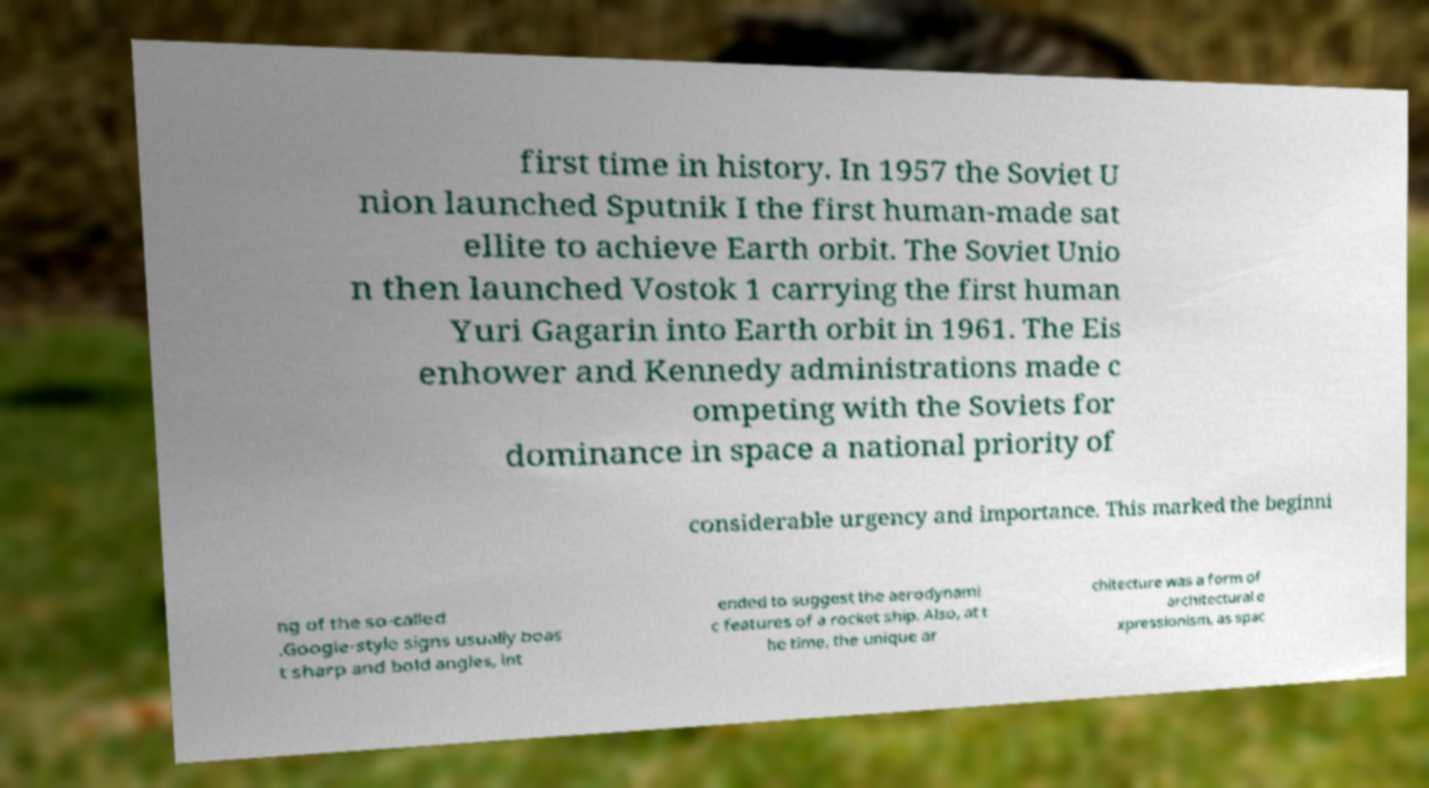Could you extract and type out the text from this image? first time in history. In 1957 the Soviet U nion launched Sputnik I the first human-made sat ellite to achieve Earth orbit. The Soviet Unio n then launched Vostok 1 carrying the first human Yuri Gagarin into Earth orbit in 1961. The Eis enhower and Kennedy administrations made c ompeting with the Soviets for dominance in space a national priority of considerable urgency and importance. This marked the beginni ng of the so-called .Googie-style signs usually boas t sharp and bold angles, int ended to suggest the aerodynami c features of a rocket ship. Also, at t he time, the unique ar chitecture was a form of architectural e xpressionism, as spac 